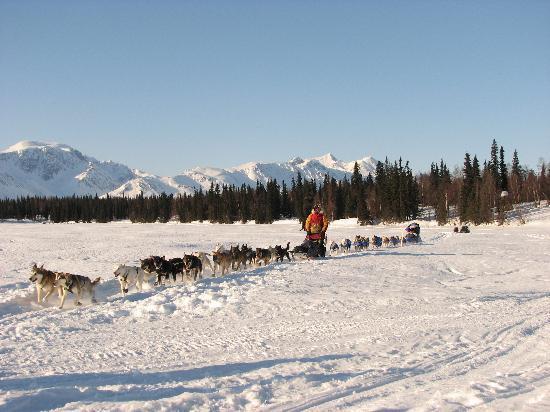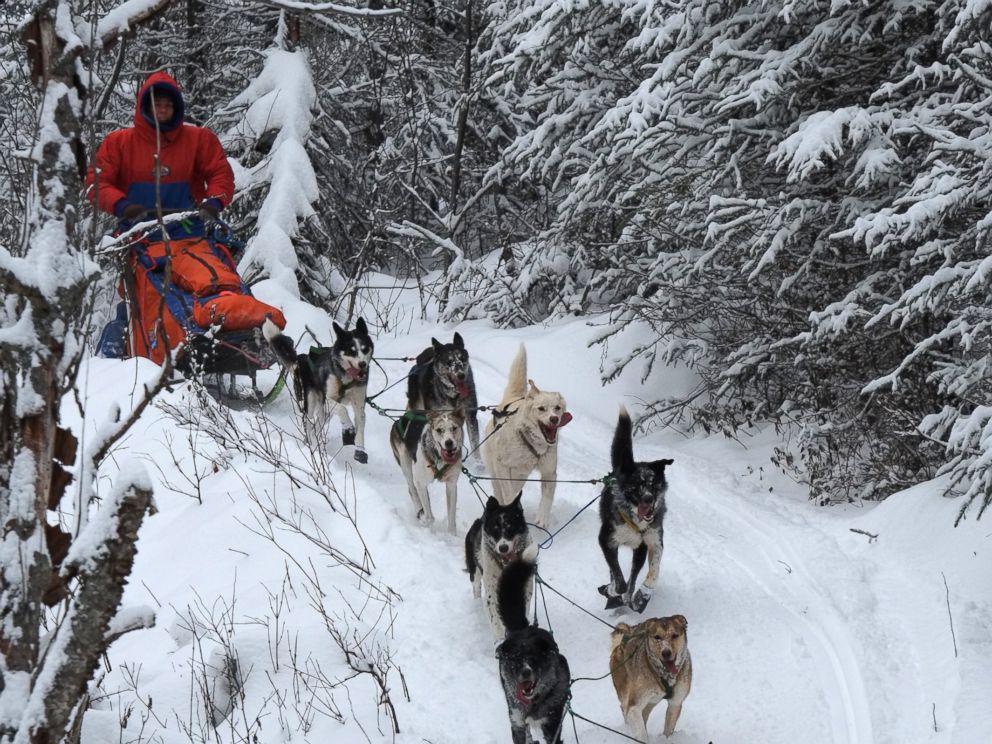The first image is the image on the left, the second image is the image on the right. Evaluate the accuracy of this statement regarding the images: "The left image shows a sled dog team moving horizontally to the right, and the right image shows a sled dog team on a path to the right of log cabins.". Is it true? Answer yes or no. No. The first image is the image on the left, the second image is the image on the right. For the images shown, is this caption "Both images contain dogs moving forward." true? Answer yes or no. Yes. 